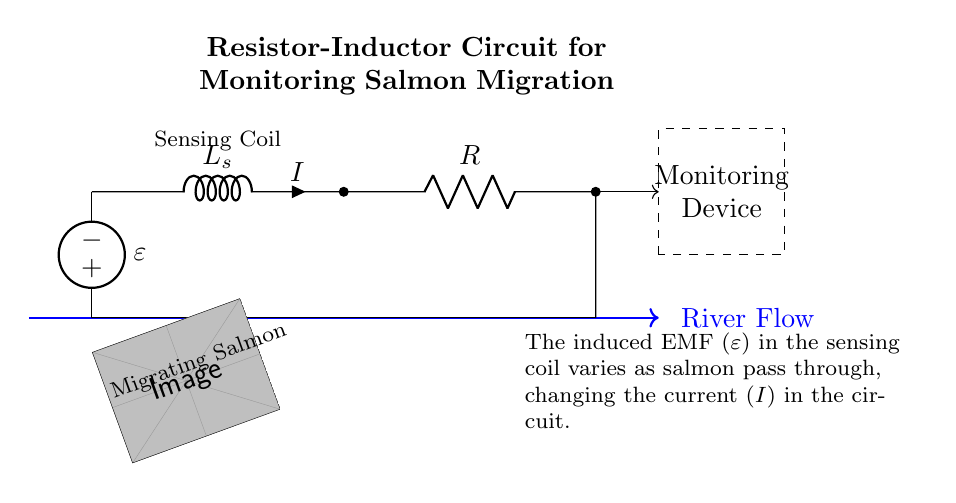What is the inductance value denoted in the circuit? The inductance is represented by the symbol L_s in the diagram, indicating a sensing coil's inductance.
Answer: L_s What component is responsible for absorbing variations in current? The inductor, shown as L_s in the diagram, absorbs changes in current flow, which is important for sensing salmon movements.
Answer: Inductor What does the voltage source represent in the circuit? The voltage source, labeled with the symbol ε, represents the induced electromotive force as salmon pass through the sensing coil.
Answer: Induced EMF How does the current change in this circuit? The current I changes as the salmon move through the river, causing variations in the induced EMF across the inductor, affecting the current flow.
Answer: It varies with salmon movement What does the resistor represent in this circuit? The resistor, denoted as R, limits the current in the circuit, ensuring that the measurements remain within acceptable ranges for monitoring.
Answer: Current limiting What is the purpose of the monitoring device in the circuit? The monitoring device collects and analyzes the data derived from the circuit to track and understand salmon migration patterns in the river.
Answer: Data collection and analysis How do salmon influence the circuit operation? As salmon pass through the sensing coil, they induce changes in EMF, which directly alter the current I in the circuit, providing insights into migration behavior.
Answer: They induce changes in EMF 